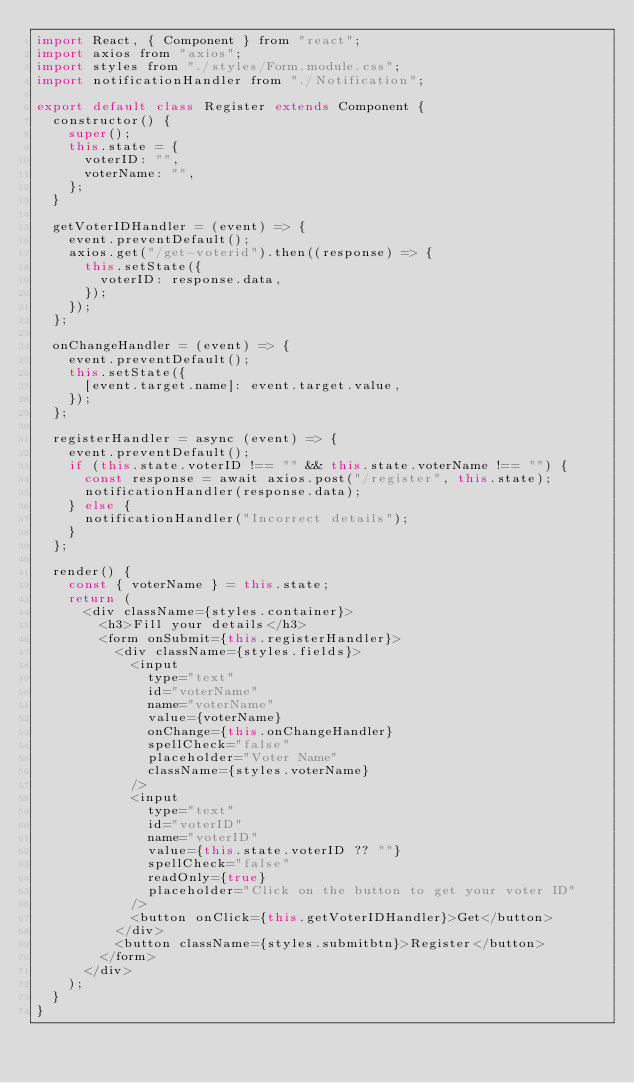<code> <loc_0><loc_0><loc_500><loc_500><_JavaScript_>import React, { Component } from "react";
import axios from "axios";
import styles from "./styles/Form.module.css";
import notificationHandler from "./Notification";

export default class Register extends Component {
  constructor() {
    super();
    this.state = {
      voterID: "",
      voterName: "",
    };
  }

  getVoterIDHandler = (event) => {
    event.preventDefault();
    axios.get("/get-voterid").then((response) => {
      this.setState({
        voterID: response.data,
      });
    });
  };

  onChangeHandler = (event) => {
    event.preventDefault();
    this.setState({
      [event.target.name]: event.target.value,
    });
  };

  registerHandler = async (event) => {
    event.preventDefault();
    if (this.state.voterID !== "" && this.state.voterName !== "") {
      const response = await axios.post("/register", this.state);
      notificationHandler(response.data);
    } else {
      notificationHandler("Incorrect details");
    }
  };

  render() {
    const { voterName } = this.state;
    return (
      <div className={styles.container}>
        <h3>Fill your details</h3>
        <form onSubmit={this.registerHandler}>
          <div className={styles.fields}>
            <input
              type="text"
              id="voterName"
              name="voterName"
              value={voterName}
              onChange={this.onChangeHandler}
              spellCheck="false"
              placeholder="Voter Name"
              className={styles.voterName}
            />
            <input
              type="text"
              id="voterID"
              name="voterID"
              value={this.state.voterID ?? ""}
              spellCheck="false"
              readOnly={true}
              placeholder="Click on the button to get your voter ID"
            />
            <button onClick={this.getVoterIDHandler}>Get</button>
          </div>
          <button className={styles.submitbtn}>Register</button>
        </form>
      </div>
    );
  }
}
</code> 